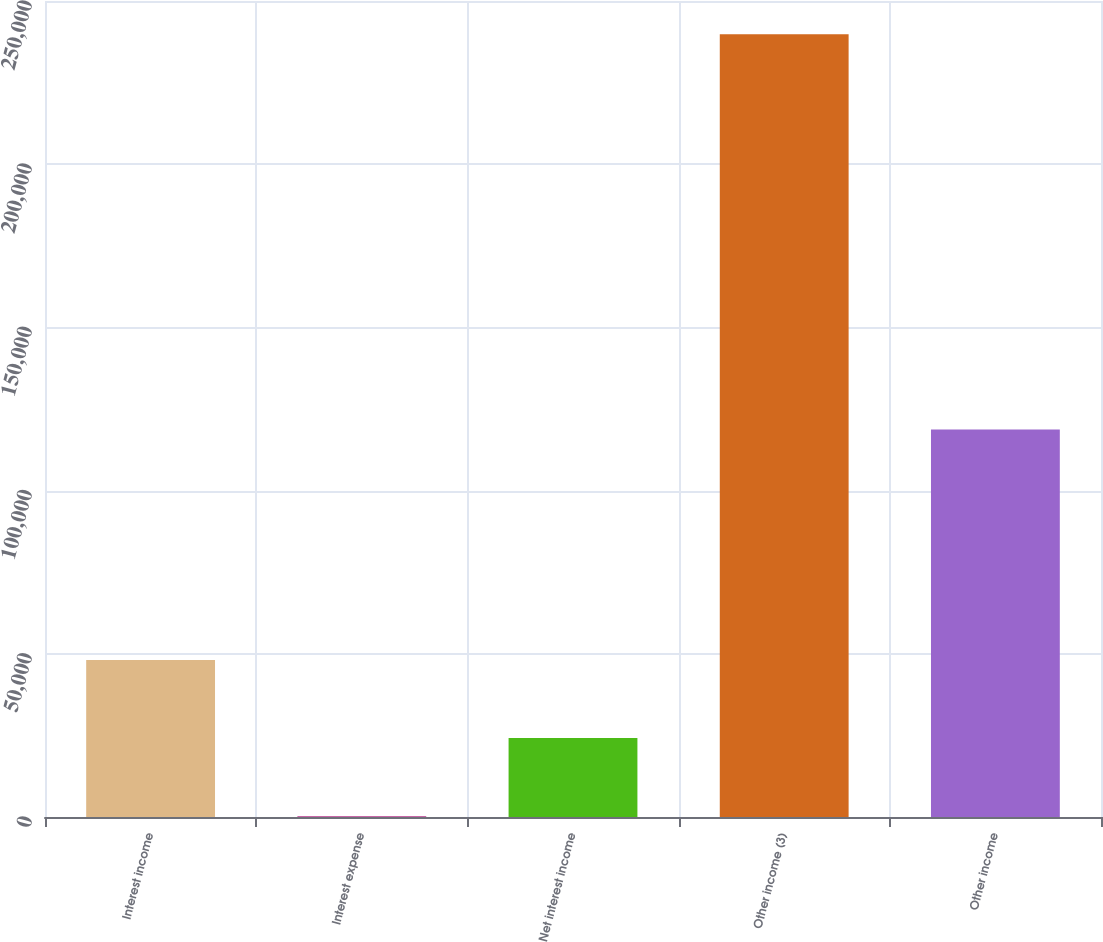<chart> <loc_0><loc_0><loc_500><loc_500><bar_chart><fcel>Interest income<fcel>Interest expense<fcel>Net interest income<fcel>Other income (3)<fcel>Other income<nl><fcel>48136.4<fcel>222<fcel>24179.2<fcel>239794<fcel>118700<nl></chart> 